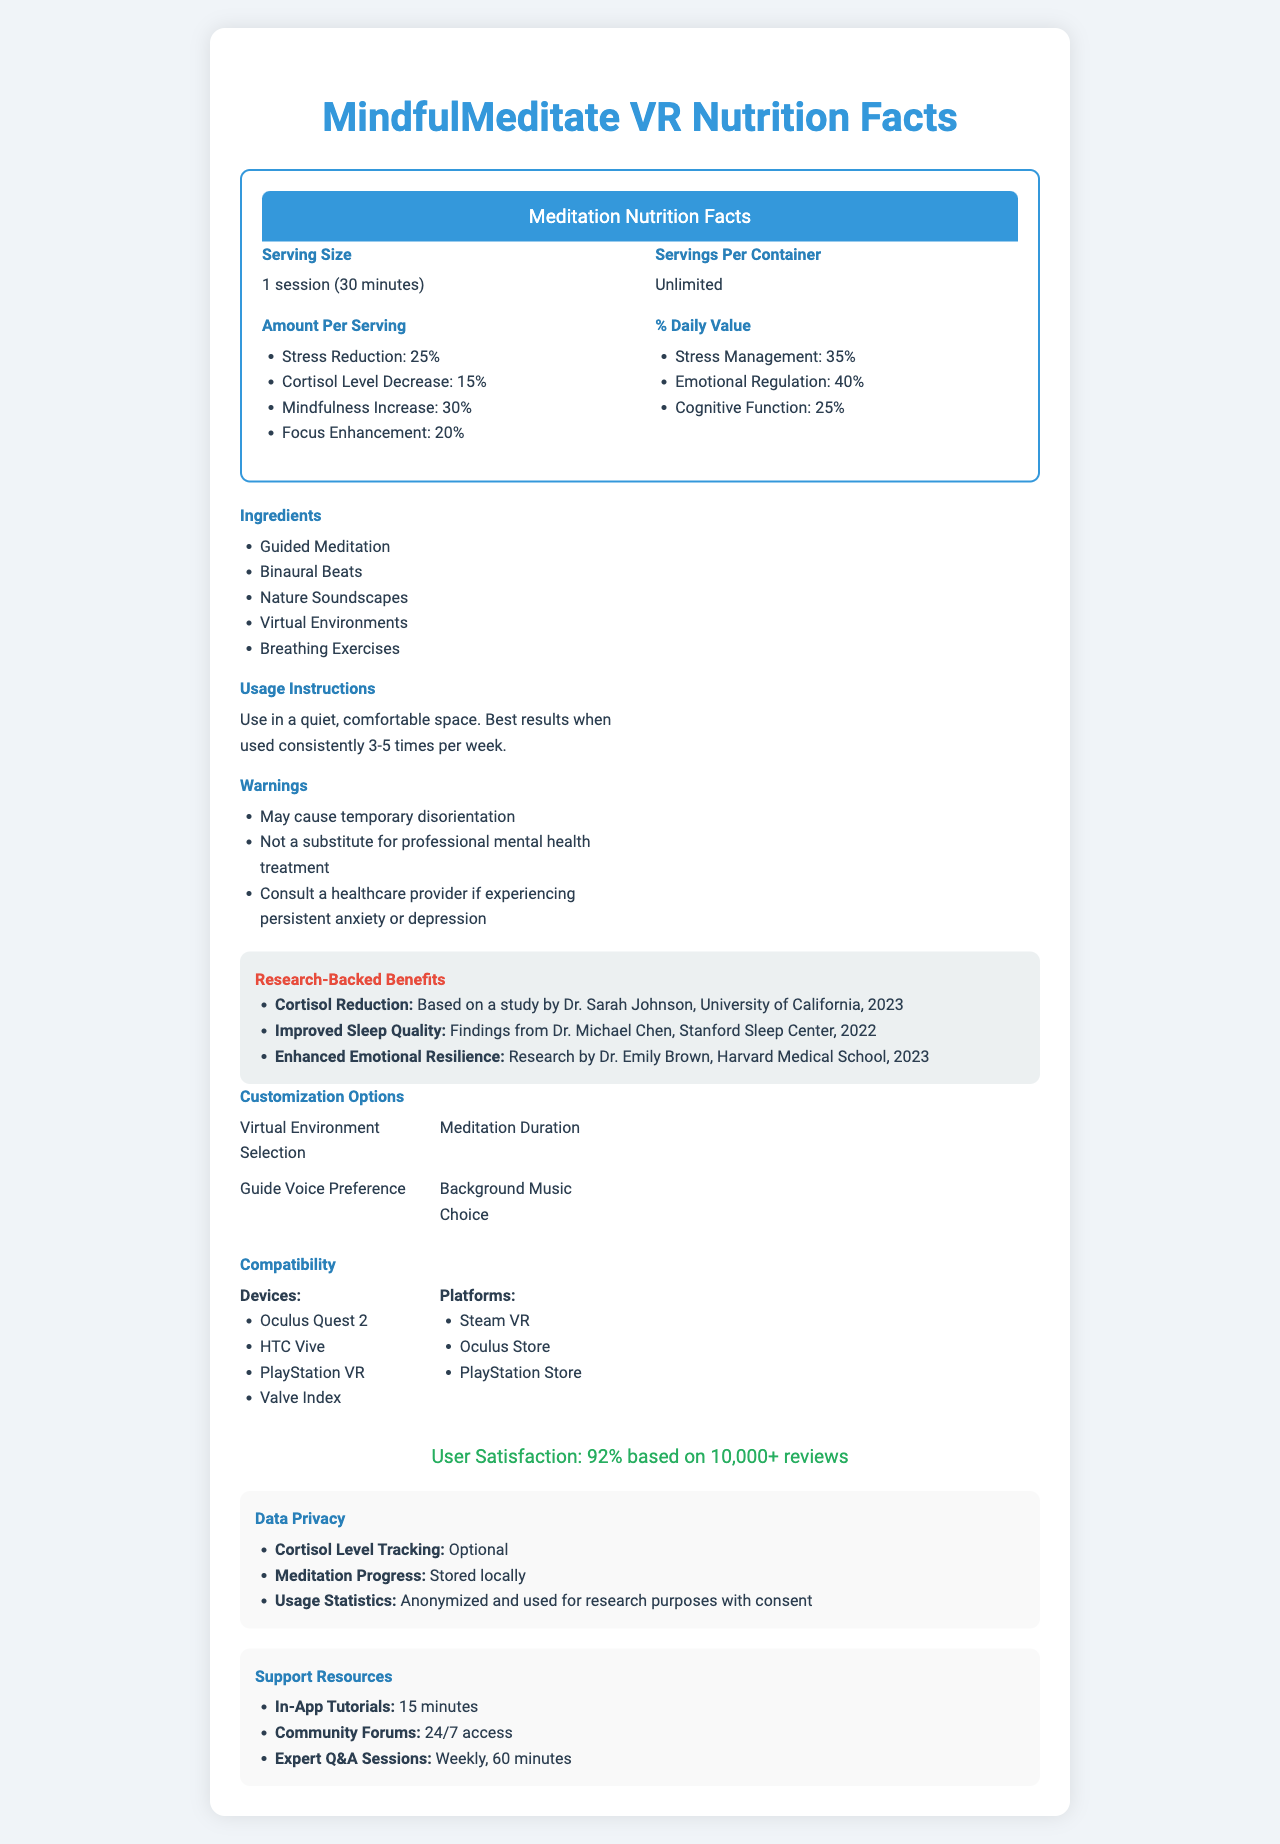What is the serving size for MindfulMeditate VR? The serving size is explicitly mentioned as "1 session (30 minutes)" under the label section.
Answer: 1 session (30 minutes) How often should MindfulMeditate VR be used for best results? The usage instructions recommend using the app consistently 3-5 times per week for best results.
Answer: 3-5 times per week What percentage does each session decrease cortisol levels? Under "Amount Per Serving", it states "Cortisol Level Decrease: 15%".
Answer: 15% Which research study supports the app's claim on cortisol reduction? The benefits section lists "Cortisol Reduction: Based on a study by Dr. Sarah Johnson, University of California, 2023".
Answer: Dr. Sarah Johnson, University of California, 2023 What is the user satisfaction rate for MindfulMeditate VR? The user satisfaction is clearly mentioned as "92% based on 10,000+ reviews".
Answer: 92% List three ingredients included in the MindfulMeditate VR sessions. These are part of the ingredients listed in the Ingredients section.
Answer: Guided Meditation, Binaural Beats, Nature Soundscapes What devices are compatible with using MindfulMeditate VR? The compatibility section lists these devices.
Answer: Oculus Quest 2, HTC Vive, PlayStation VR, Valve Index What should you do if you experience persistent anxiety or depression while using MindfulMeditate VR? The warnings section advises consulting a healthcare provider in such cases.
Answer: Consult a healthcare provider What are the benefits of using MindfulMeditate VR according to the document? These benefits are listed under the "Amount Per Serving" section.
Answer: Stress reduction, cortisol level decrease, mindfulness increase, focus enhancement True or false: MindfulMeditate VR can serve as a substitute for professional mental health treatment. The warnings explicitly state that it is not a substitute for professional mental health treatment.
Answer: False Which of the following is NOT a customization option for MindfulMeditate VR? A. Meditation Duration B. Guide Voice Preference C. Serving Size D. Background Music Choice Serving Size is not listed as a customization option, while the others are.
Answer: C How long are the in-app tutorials available in MindfulMeditate VR? A. 10 minutes B. 15 minutes C. 20 minutes D. 30 minutes The support resources section states that in-app tutorials are available for 15 minutes.
Answer: B Describe the main idea of the document. The main idea encompasses all sections detailing usage, benefits, precautions, and additional features of the MindfulMeditate VR application.
Answer: The document provides a detailed overview of the MindfulMeditate VR product, including its serving size, benefits per session, daily values, ingredients, usage instructions, warnings, research-backed benefits, customization options, compatibility, user satisfaction, data privacy, and support resources. How does MindfulMeditate VR impact cognitive function according to the Daily Value information? The "% Daily Value" section indicates that cognitive function is enhanced by 25%.
Answer: It enhances cognitive function by 25% What do you need to use the community forums for MindfulMeditate VR? The support resources section lists 24/7 access as a feature of the community forums.
Answer: 24/7 access What is the improvement in emotional regulation as a benefit of using MindfulMeditate VR? The "% Daily Value" section mentions that emotional regulation has a 40% improvement.
Answer: 40% Can you determine the exact long-term impacts of using MindfulMeditate VR beyond the presented data? The document only provides specific immediate benefits and does not discuss long-term impacts beyond the mentioned studies and benefits.
Answer: Not enough information 